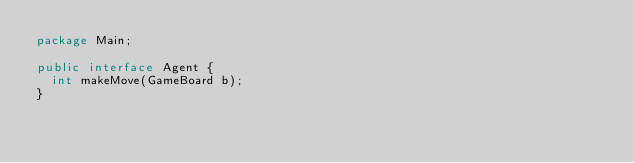<code> <loc_0><loc_0><loc_500><loc_500><_Java_>package Main;

public interface Agent {
	int makeMove(GameBoard b);
}
</code> 